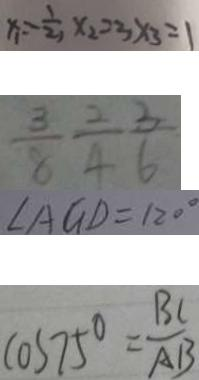<formula> <loc_0><loc_0><loc_500><loc_500>x _ { 1 } = - \frac { 1 } { 2 } , x _ { 2 } = 3 x _ { 3 } = 1 
 \frac { 3 } { 6 } \frac { 2 } { 4 } \frac { 3 } { 6 } 
 \angle A G D = 1 2 0 ^ { \circ } 
 C O S 7 5 ^ { \circ } = \frac { B C } { A B }</formula> 